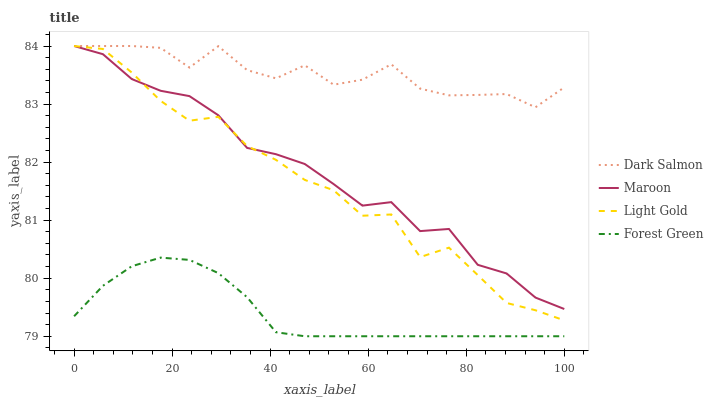Does Forest Green have the minimum area under the curve?
Answer yes or no. Yes. Does Dark Salmon have the maximum area under the curve?
Answer yes or no. Yes. Does Light Gold have the minimum area under the curve?
Answer yes or no. No. Does Light Gold have the maximum area under the curve?
Answer yes or no. No. Is Forest Green the smoothest?
Answer yes or no. Yes. Is Dark Salmon the roughest?
Answer yes or no. Yes. Is Light Gold the smoothest?
Answer yes or no. No. Is Light Gold the roughest?
Answer yes or no. No. Does Forest Green have the lowest value?
Answer yes or no. Yes. Does Light Gold have the lowest value?
Answer yes or no. No. Does Maroon have the highest value?
Answer yes or no. Yes. Is Forest Green less than Maroon?
Answer yes or no. Yes. Is Maroon greater than Forest Green?
Answer yes or no. Yes. Does Maroon intersect Light Gold?
Answer yes or no. Yes. Is Maroon less than Light Gold?
Answer yes or no. No. Is Maroon greater than Light Gold?
Answer yes or no. No. Does Forest Green intersect Maroon?
Answer yes or no. No. 